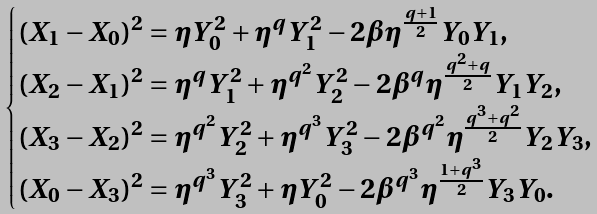<formula> <loc_0><loc_0><loc_500><loc_500>\begin{cases} ( X _ { 1 } - X _ { 0 } ) ^ { 2 } = \eta Y _ { 0 } ^ { 2 } + \eta ^ { q } Y _ { 1 } ^ { 2 } - 2 \beta \eta ^ { \frac { q + 1 } { 2 } } Y _ { 0 } Y _ { 1 } , \\ ( X _ { 2 } - X _ { 1 } ) ^ { 2 } = \eta ^ { q } Y _ { 1 } ^ { 2 } + \eta ^ { q ^ { 2 } } Y _ { 2 } ^ { 2 } - 2 \beta ^ { q } \eta ^ { \frac { q ^ { 2 } + q } { 2 } } Y _ { 1 } Y _ { 2 } , \\ ( X _ { 3 } - X _ { 2 } ) ^ { 2 } = \eta ^ { q ^ { 2 } } Y _ { 2 } ^ { 2 } + \eta ^ { q ^ { 3 } } Y _ { 3 } ^ { 2 } - 2 \beta ^ { q ^ { 2 } } \eta ^ { \frac { q ^ { 3 } + q ^ { 2 } } { 2 } } Y _ { 2 } Y _ { 3 } , \\ ( X _ { 0 } - X _ { 3 } ) ^ { 2 } = \eta ^ { q ^ { 3 } } Y _ { 3 } ^ { 2 } + \eta Y _ { 0 } ^ { 2 } - 2 \beta ^ { q ^ { 3 } } \eta ^ { \frac { 1 + q ^ { 3 } } { 2 } } Y _ { 3 } Y _ { 0 } . \\ \end{cases}</formula> 